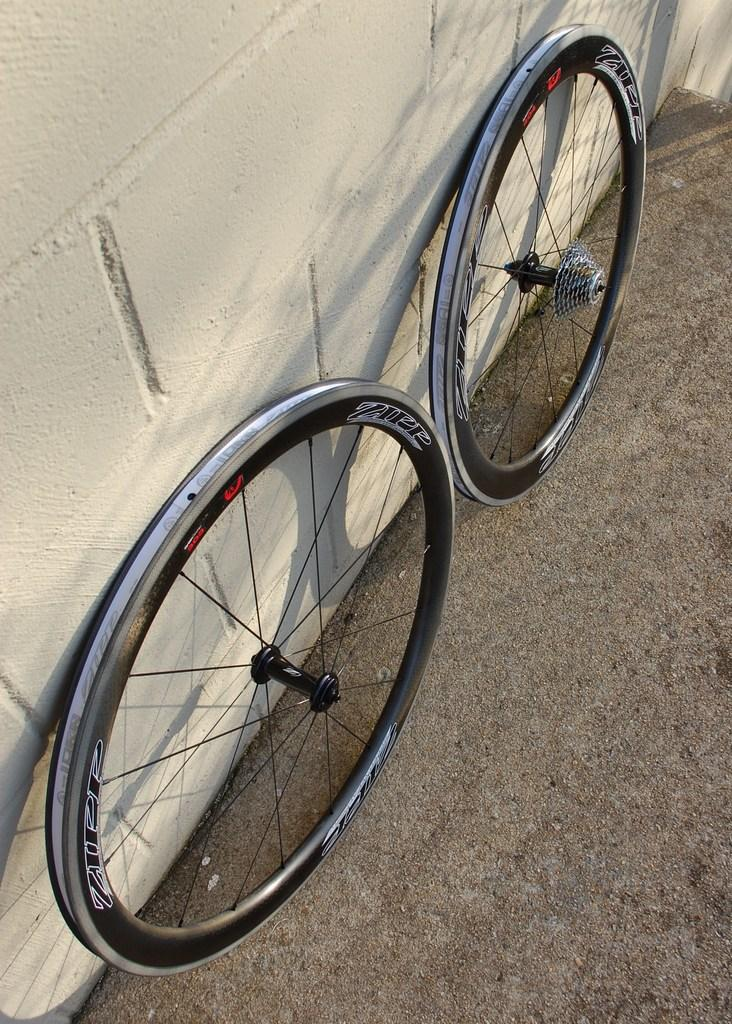What objects are on the floor in the image? There are two wheels of a bicycle on the floor. Where are the wheels located in relation to the image? The wheels are at the bottom of the image. What can be seen in the background of the image? There is a wall in the background of the image. Reasoning: Let'g: Let's think step by step in order to produce the conversation. We start by identifying the main subject in the image, which is the two wheels of a bicycle on the floor. Then, we describe their location within the image, noting that they are at the bottom. Finally, we mention the background element, which is a wall. Each question is designed to elicit a specific detail about the image that is known from the provided facts. Absurd Question/Answer: What type of shirt is hanging on the wall in the image? There is no shirt present in the image; the background element is a wall without any clothing items. How many boats are visible in the image? There are no boats visible in the image; it only features two bicycle wheels on the floor and a wall in the background. What type of basin is visible in the image? There is no basin present in the image; it only features two bicycle wheels on the floor and a wall in the background. 